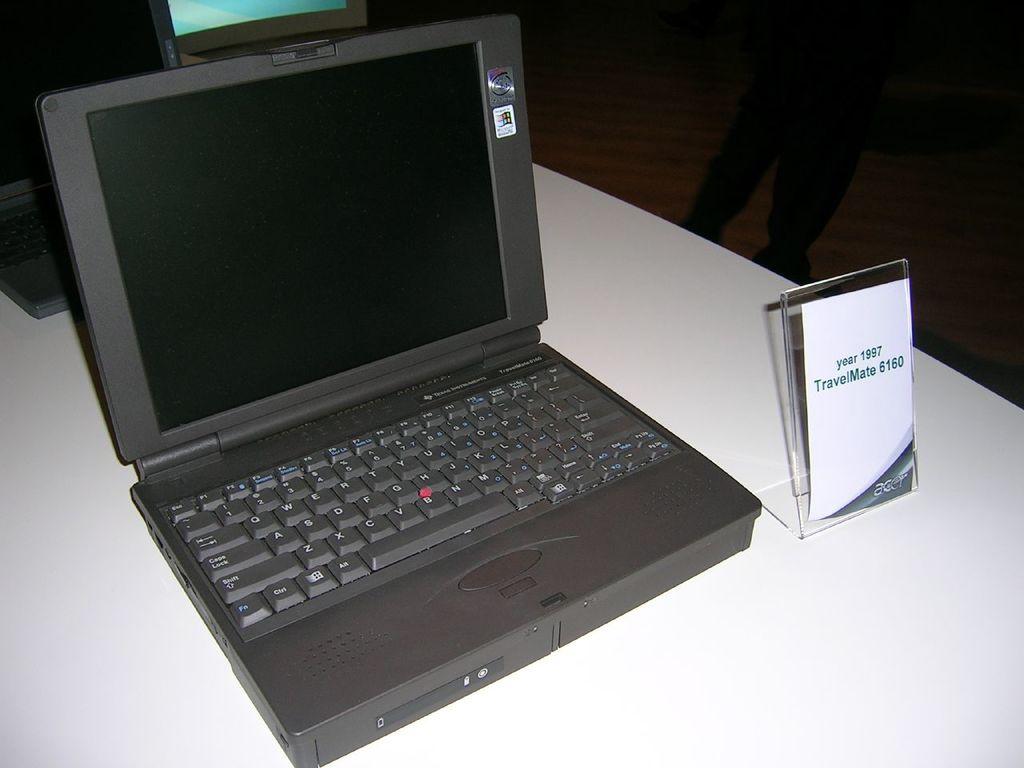What is te model of this laptop?
Keep it short and to the point. Travelmate 6160. What is one key that is on the laptop keyboard?
Your response must be concise. A. 